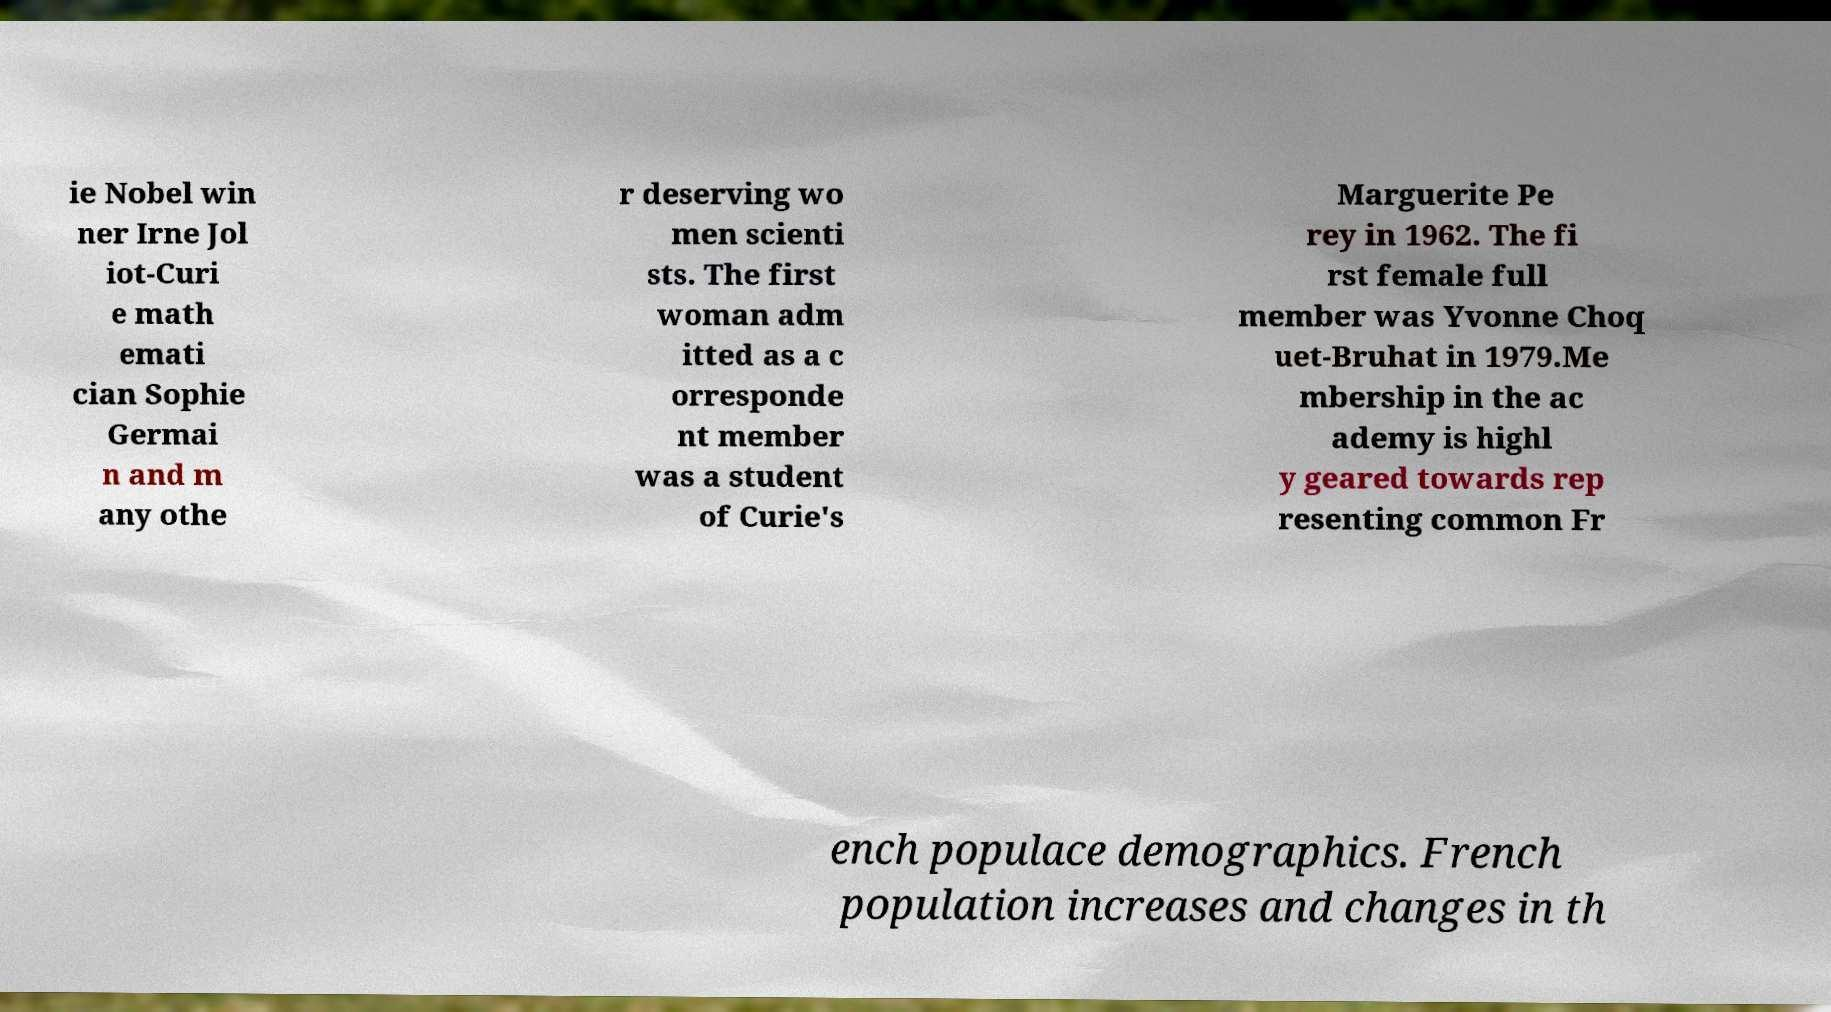Could you assist in decoding the text presented in this image and type it out clearly? ie Nobel win ner Irne Jol iot-Curi e math emati cian Sophie Germai n and m any othe r deserving wo men scienti sts. The first woman adm itted as a c orresponde nt member was a student of Curie's Marguerite Pe rey in 1962. The fi rst female full member was Yvonne Choq uet-Bruhat in 1979.Me mbership in the ac ademy is highl y geared towards rep resenting common Fr ench populace demographics. French population increases and changes in th 